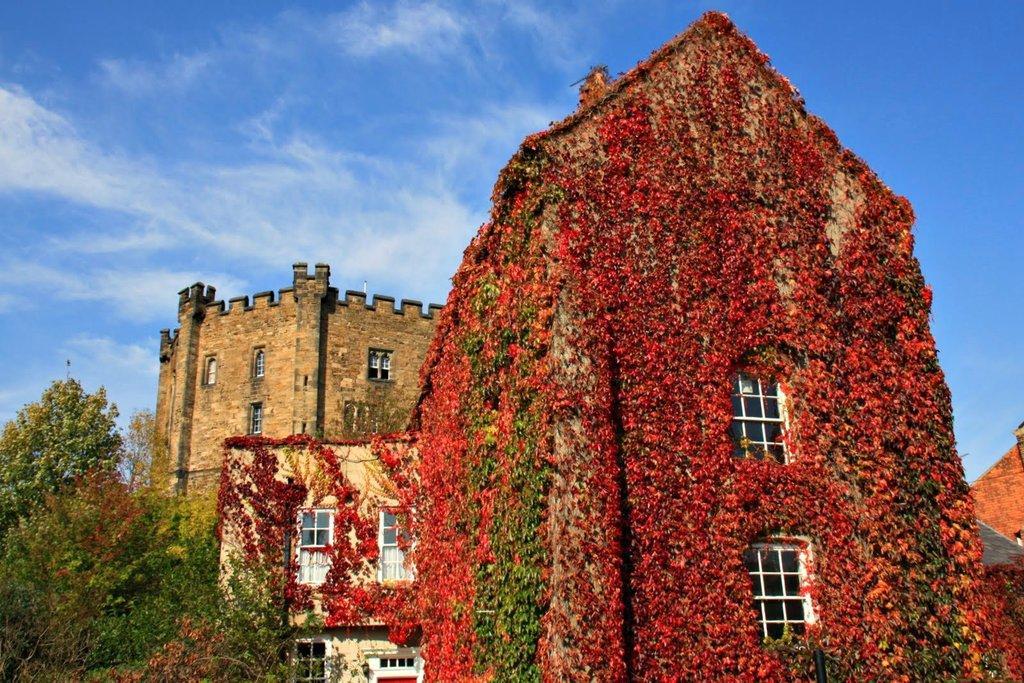In one or two sentences, can you explain what this image depicts? This image is taken outdoors. At the top of the image there is a sky with clouds. On the left side of the image there are a few trees. In the background there is a building and a house with walls, windows and roofs. In the middle of the image there is a building and there are many creepers on the building. 